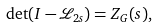Convert formula to latex. <formula><loc_0><loc_0><loc_500><loc_500>\det ( I - { \mathcal { L } } _ { 2 s } ) = Z _ { G } ( s ) ,</formula> 